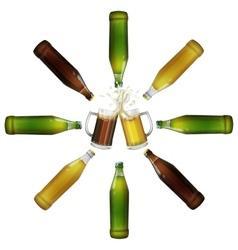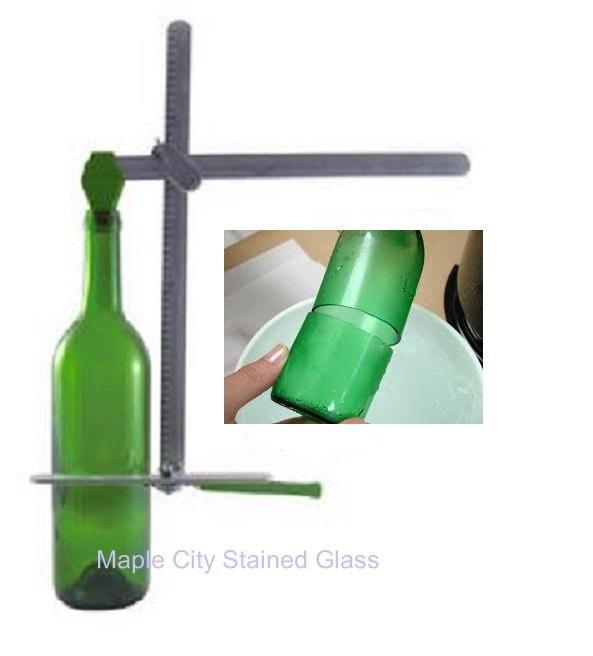The first image is the image on the left, the second image is the image on the right. Given the left and right images, does the statement "In one image, the bottles are capped and have distinctive matching labels, while the other image is of empty, uncapped bottles." hold true? Answer yes or no. No. The first image is the image on the left, the second image is the image on the right. Considering the images on both sides, is "An image includes at least one green bottle displayed horizontally." valid? Answer yes or no. Yes. The first image is the image on the left, the second image is the image on the right. Assess this claim about the two images: "One image includes at least one glass containing beer, along with at least one beer bottle.". Correct or not? Answer yes or no. Yes. 